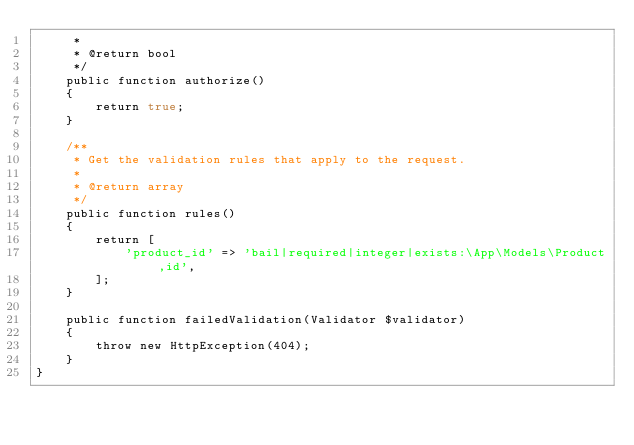Convert code to text. <code><loc_0><loc_0><loc_500><loc_500><_PHP_>     *
     * @return bool
     */
    public function authorize()
    {
        return true;
    }

    /**
     * Get the validation rules that apply to the request.
     *
     * @return array
     */
    public function rules()
    {
        return [
            'product_id' => 'bail|required|integer|exists:\App\Models\Product,id',
        ];
    }

    public function failedValidation(Validator $validator)
    {
        throw new HttpException(404);
    }
}
</code> 